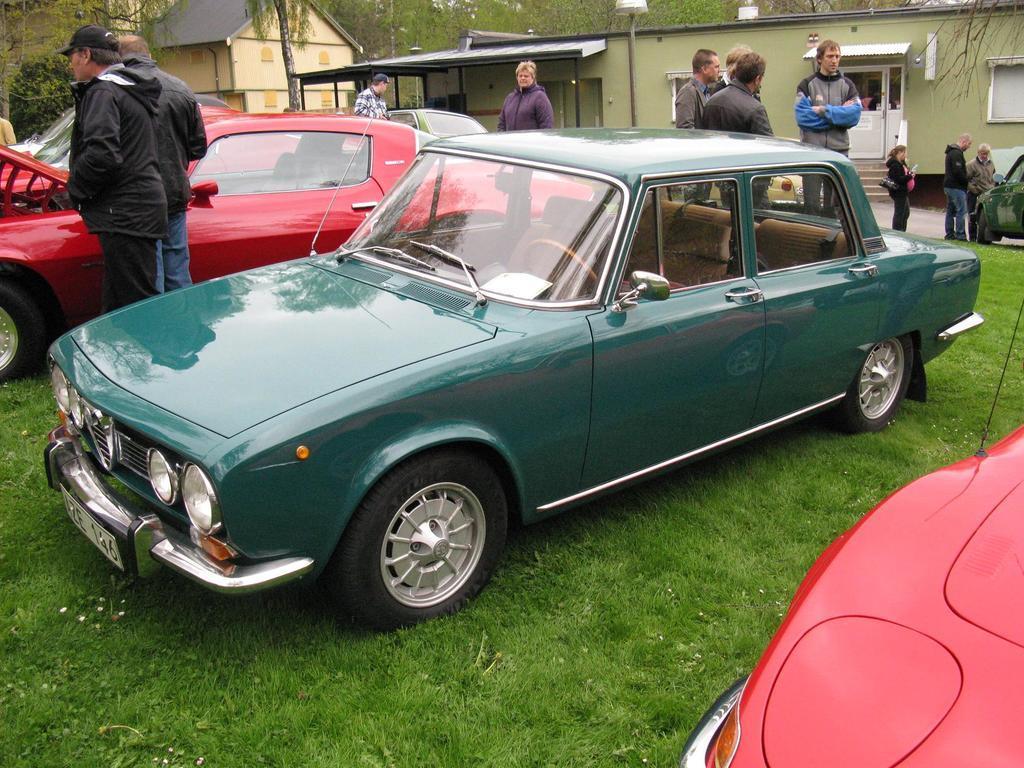How would you summarize this image in a sentence or two? In this picture we can see there are vehicles and people on the grass. Behind the vehicles, there are houses and trees. 